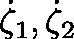Convert formula to latex. <formula><loc_0><loc_0><loc_500><loc_500>\dot { \zeta } _ { 1 } , \dot { \zeta } _ { 2 }</formula> 